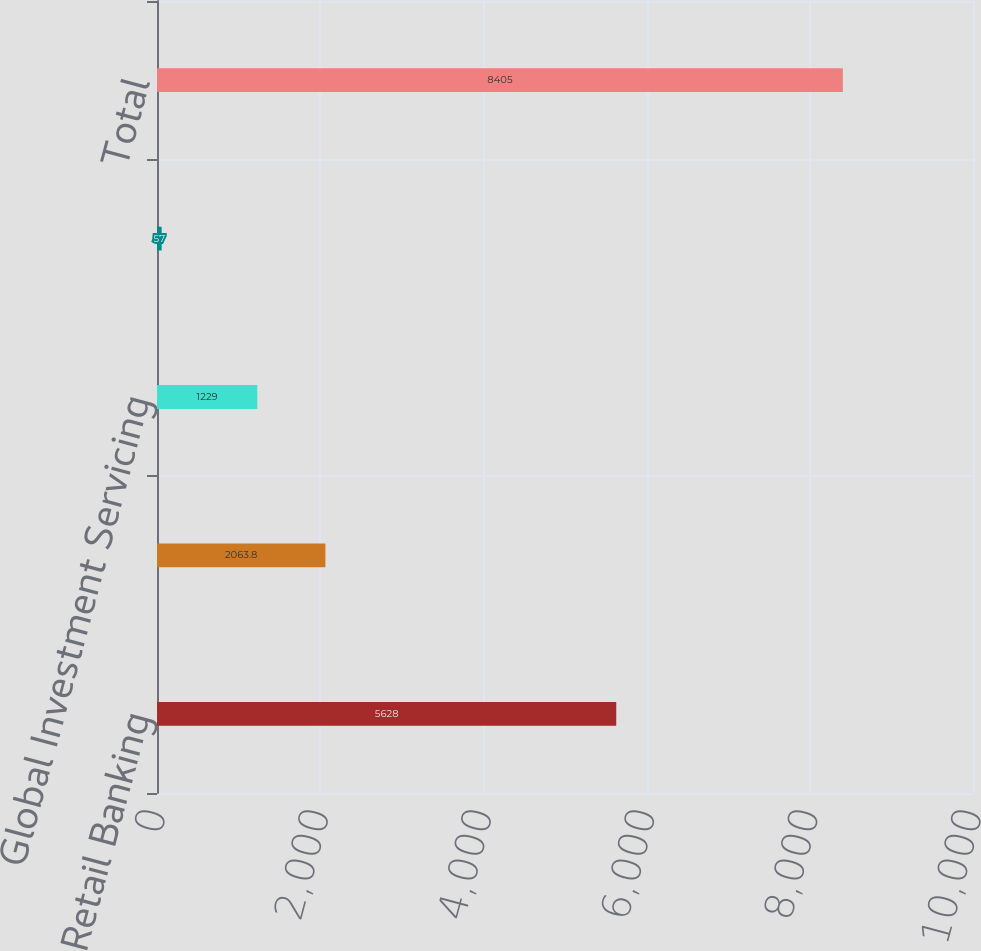<chart> <loc_0><loc_0><loc_500><loc_500><bar_chart><fcel>Retail Banking<fcel>Corporate & Institutional<fcel>Global Investment Servicing<fcel>BlackRock<fcel>Total<nl><fcel>5628<fcel>2063.8<fcel>1229<fcel>57<fcel>8405<nl></chart> 